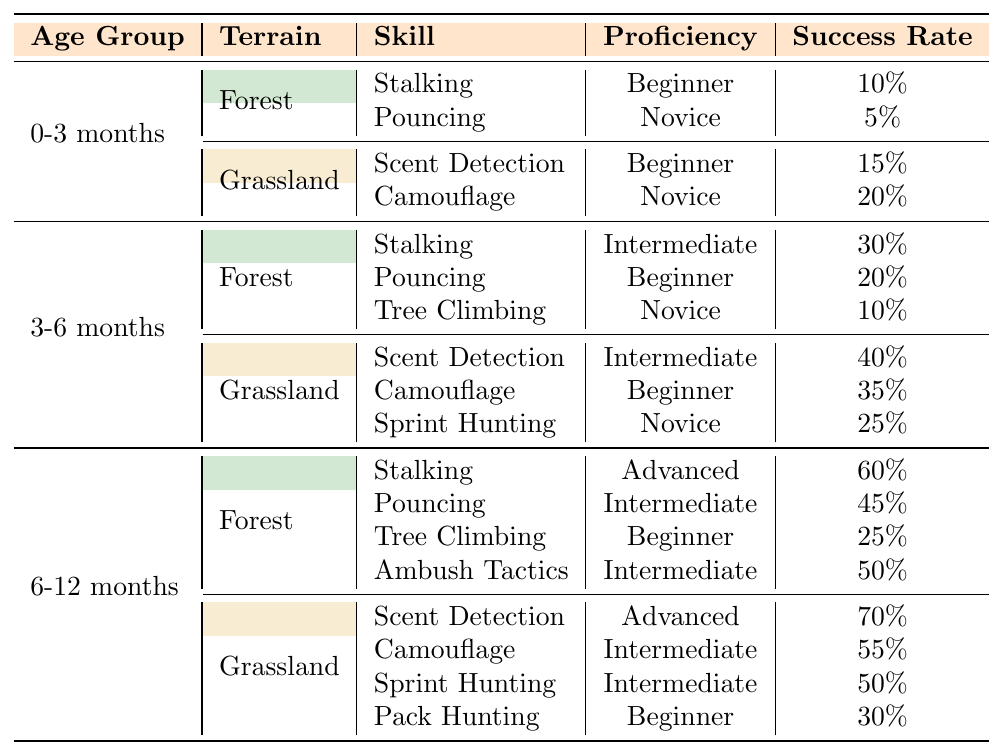What is the proficiency level for "Stalking" in the "Grassland" terrain at 3-6 months? According to the table, in the "Grassland" terrain for the 3-6 months age group, the proficiency level for "Scent Detection" is Intermediate, while "Stalking" is considered Intermediate as well.
Answer: Intermediate Which age group has the highest success rate for "Scent Detection"? The table shows that "Scent Detection" has a success rate of 70% in the 6-12 months age group, which is higher than the rates in the other age groups.
Answer: 6-12 months For the "Forest" terrain, what is the total number of skills listed for the 6-12 months age group? In the Forest terrain for the 6-12 months age group, there are four skills listed: "Stalking", "Pouncing", "Tree Climbing", and "Ambush Tactics", which totals to four skills.
Answer: 4 Is "Pouncing" more successful in the 0-3 months age group or the 6-12 months age group? "Pouncing" has a success rate of 5% in the 0-3 months age group and 45% in the 6-12 months age group, indicating that it is significantly more successful in the latter.
Answer: 6-12 months What is the average success rate of "Camouflage" across all age groups? "Camouflage" success rates are 20% (0-3 months), 35% (3-6 months), 55% (6-12 months). Adding these gives 20 + 35 + 55 = 110, and dividing by 3 results in an average of 36.67%.
Answer: 36.67% Are there any beginner proficiency skills in the Grassland terrain for any age group? Yes, the table indicates that "Camouflage" in the 0-3 months and "Pack Hunting" in the 6-12 months age group are both classified as beginner proficiency for the Grassland terrain.
Answer: Yes Which skill has the lowest success rate in the "Forest" terrain for 0-3 months? Looking at the "Forest" terrain for the 0-3 month age group, "Pouncing" has the lowest success rate of 5%, compared to "Stalking", which has 10%.
Answer: Pouncing What change occurs in "Tree Climbing" from the 3-6 months age group to the 6-12 months age group in terms of proficiency? The proficiency for "Tree Climbing" increases from Novice in the 3-6 months age group to Beginner in the 6-12 months age group, indicating a decrease in proficiency level.
Answer: Decrease How many skills are listed under the 3-6 months age group and Grassland terrain? Under the 3-6 months age group and Grassland terrain, there are three skills listed: "Scent Detection", "Camouflage", and "Sprint Hunting".
Answer: 3 What is the difference in success rate for "Stalking" between the 6-12 months and 0-3 months age groups? The success rate for "Stalking" is 60% in the 6-12 months age group and 10% in the 0-3 months age group. The difference is 60% - 10% = 50%.
Answer: 50% 